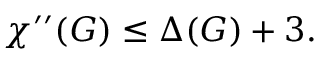<formula> <loc_0><loc_0><loc_500><loc_500>\chi ^ { \prime \prime } ( G ) \leq \Delta ( G ) + 3 .</formula> 